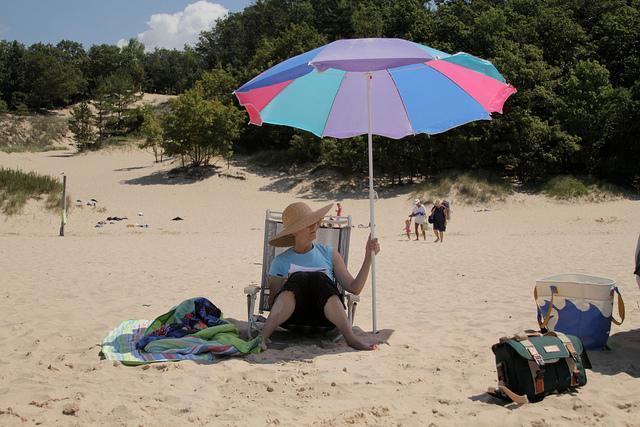How many handbags are in the photo?
Give a very brief answer. 2. 